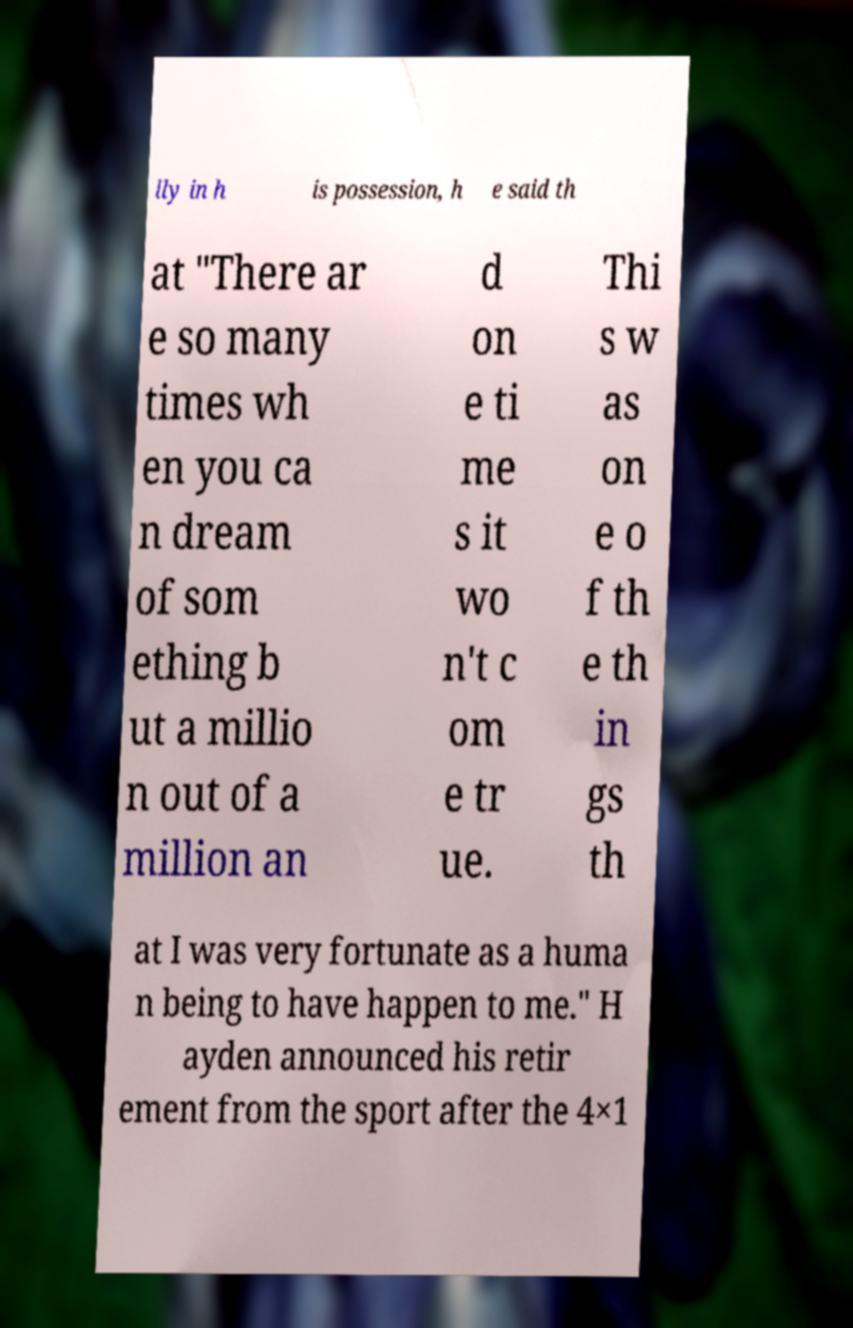For documentation purposes, I need the text within this image transcribed. Could you provide that? lly in h is possession, h e said th at "There ar e so many times wh en you ca n dream of som ething b ut a millio n out of a million an d on e ti me s it wo n't c om e tr ue. Thi s w as on e o f th e th in gs th at I was very fortunate as a huma n being to have happen to me." H ayden announced his retir ement from the sport after the 4×1 